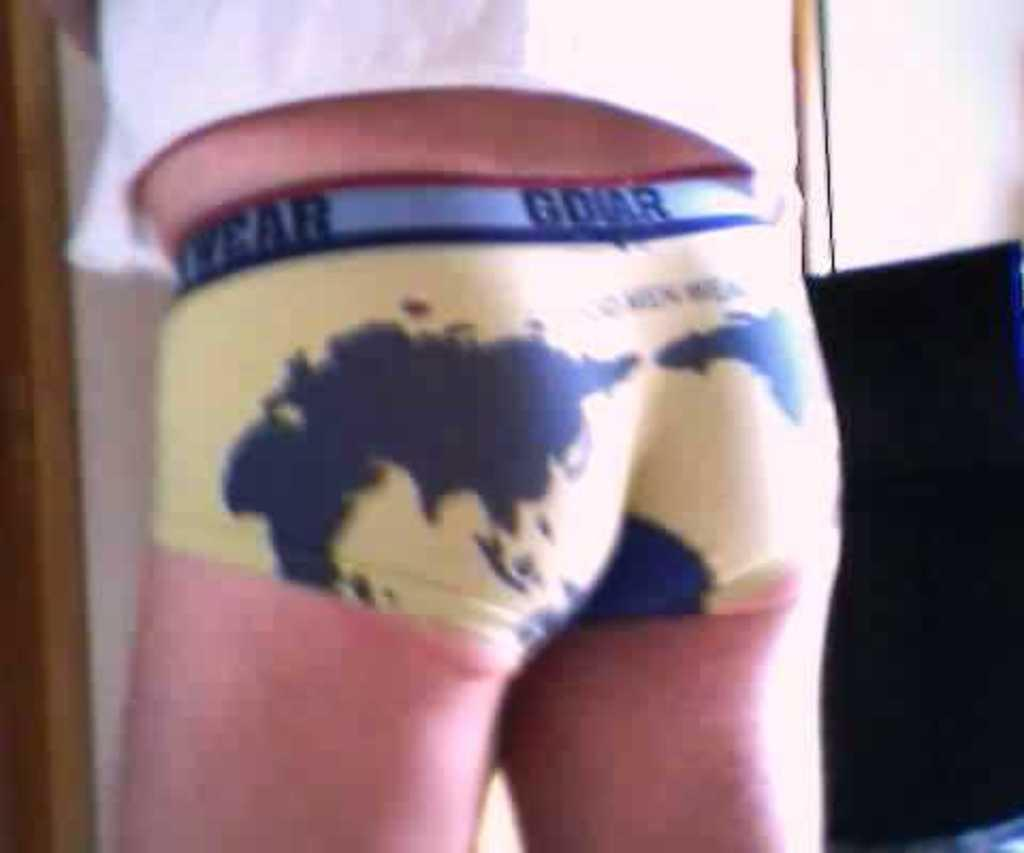Who or what is present in the image? There is a person in the image. What can be seen in the background of the image? There is a wall in the image. Are there any objects that are partially visible in the image? Yes, there is an object truncated towards the left of the image and another object truncated towards the right of the image. What type of brush is being used by the band to create peace in the image? There is no brush, band, or reference to peace in the image. 